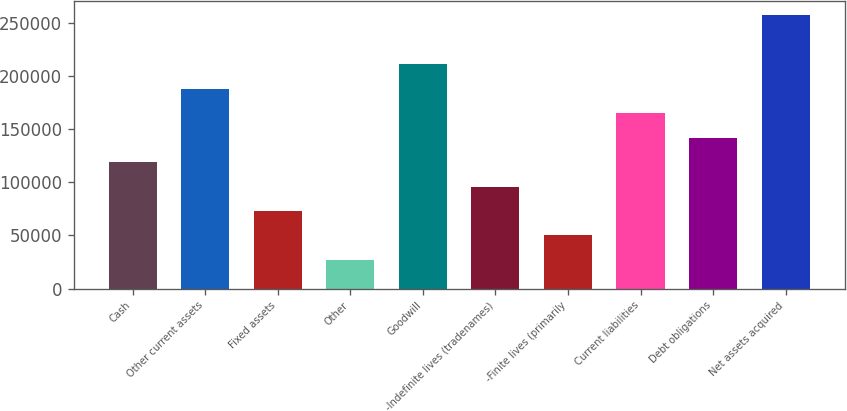Convert chart to OTSL. <chart><loc_0><loc_0><loc_500><loc_500><bar_chart><fcel>Cash<fcel>Other current assets<fcel>Fixed assets<fcel>Other<fcel>Goodwill<fcel>-Indefinite lives (tradenames)<fcel>-Finite lives (primarily<fcel>Current liabilities<fcel>Debt obligations<fcel>Net assets acquired<nl><fcel>119000<fcel>188000<fcel>73000<fcel>27000<fcel>211000<fcel>96000<fcel>50000<fcel>165000<fcel>142000<fcel>257000<nl></chart> 